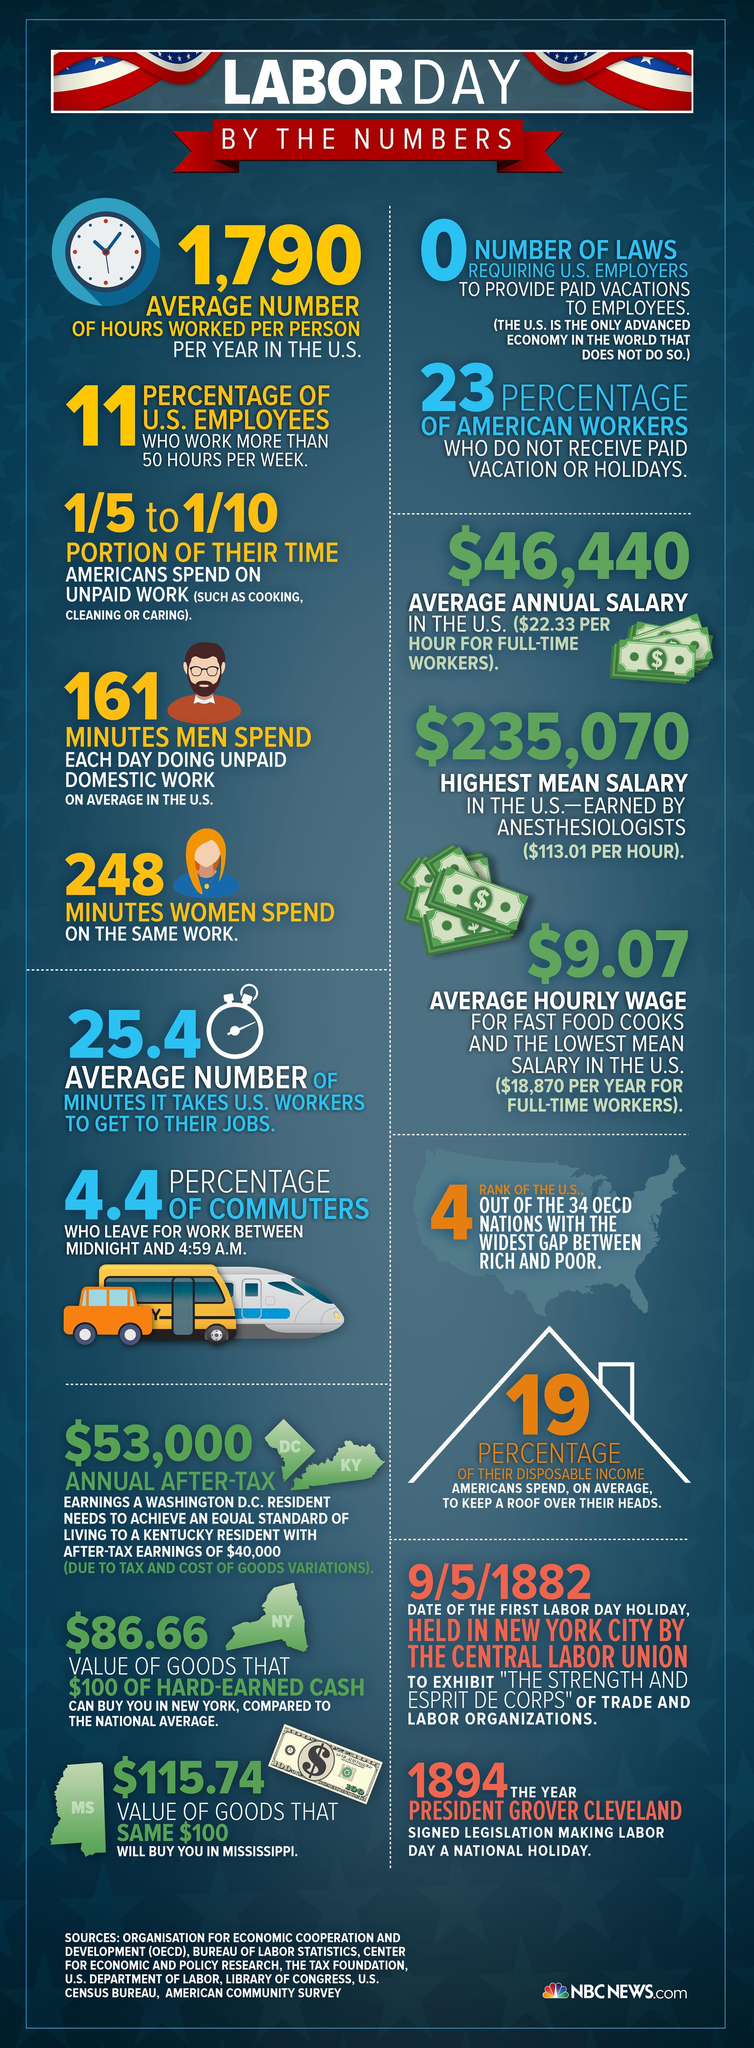how many laws are there in US requiring to provide paid vacations to employers
Answer the question with a short phrase. 0 What % of US employees work more than 50 hours per week 11 How many minutes does it take for an US worker to get to their jobs on an average 25.4 how much minutes more than men do women spend on a average each day doing unpaid domestic work 87 what is 19% of the americans disposal income on an average spent on to keep a roof over their heads How much more in dollars should a DC resident earn more than a KY resident to achieve an equal standard of living 13000 who has the lowest mean salary in the US fast food cooks 